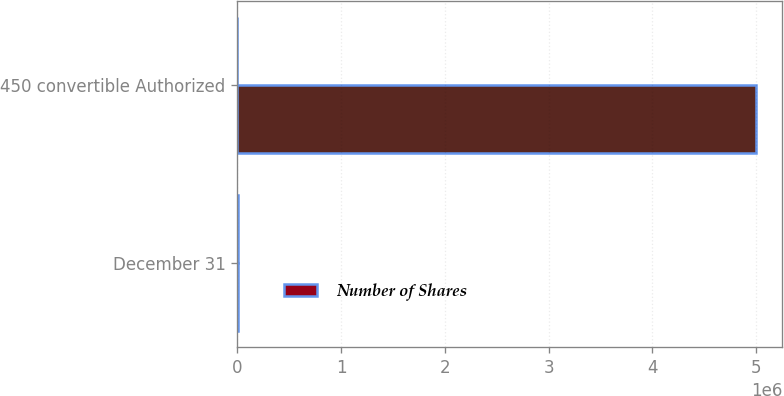Convert chart. <chart><loc_0><loc_0><loc_500><loc_500><stacked_bar_chart><ecel><fcel>December 31<fcel>450 convertible Authorized<nl><fcel>nan<fcel>2007<fcel>5e+06<nl><fcel>Number of Shares<fcel>2007<fcel>250<nl></chart> 